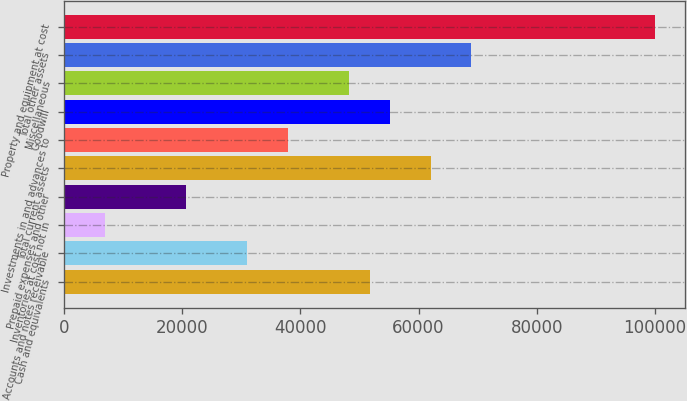Convert chart to OTSL. <chart><loc_0><loc_0><loc_500><loc_500><bar_chart><fcel>Cash and equivalents<fcel>Accounts and notes receivable<fcel>Inventories at cost not in<fcel>Prepaid expenses and other<fcel>Total current assets<fcel>Investments in and advances to<fcel>Goodwill<fcel>Miscellaneous<fcel>Total other assets<fcel>Property and equipment at cost<nl><fcel>51719.4<fcel>31035<fcel>6903.12<fcel>20692.8<fcel>62061.7<fcel>37929.8<fcel>55166.9<fcel>48272<fcel>68956.5<fcel>99983.2<nl></chart> 